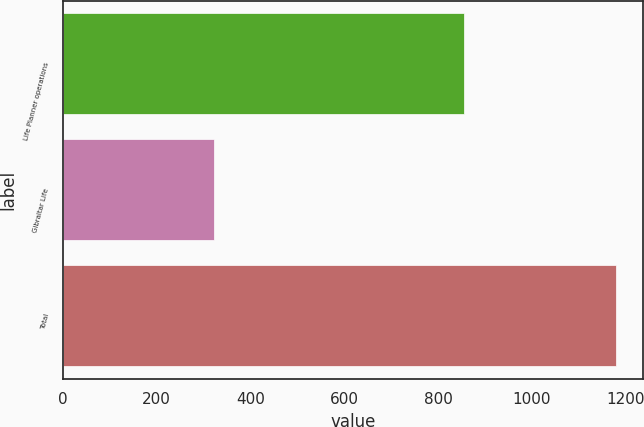<chart> <loc_0><loc_0><loc_500><loc_500><bar_chart><fcel>Life Planner operations<fcel>Gibraltar Life<fcel>Total<nl><fcel>856<fcel>323<fcel>1179<nl></chart> 